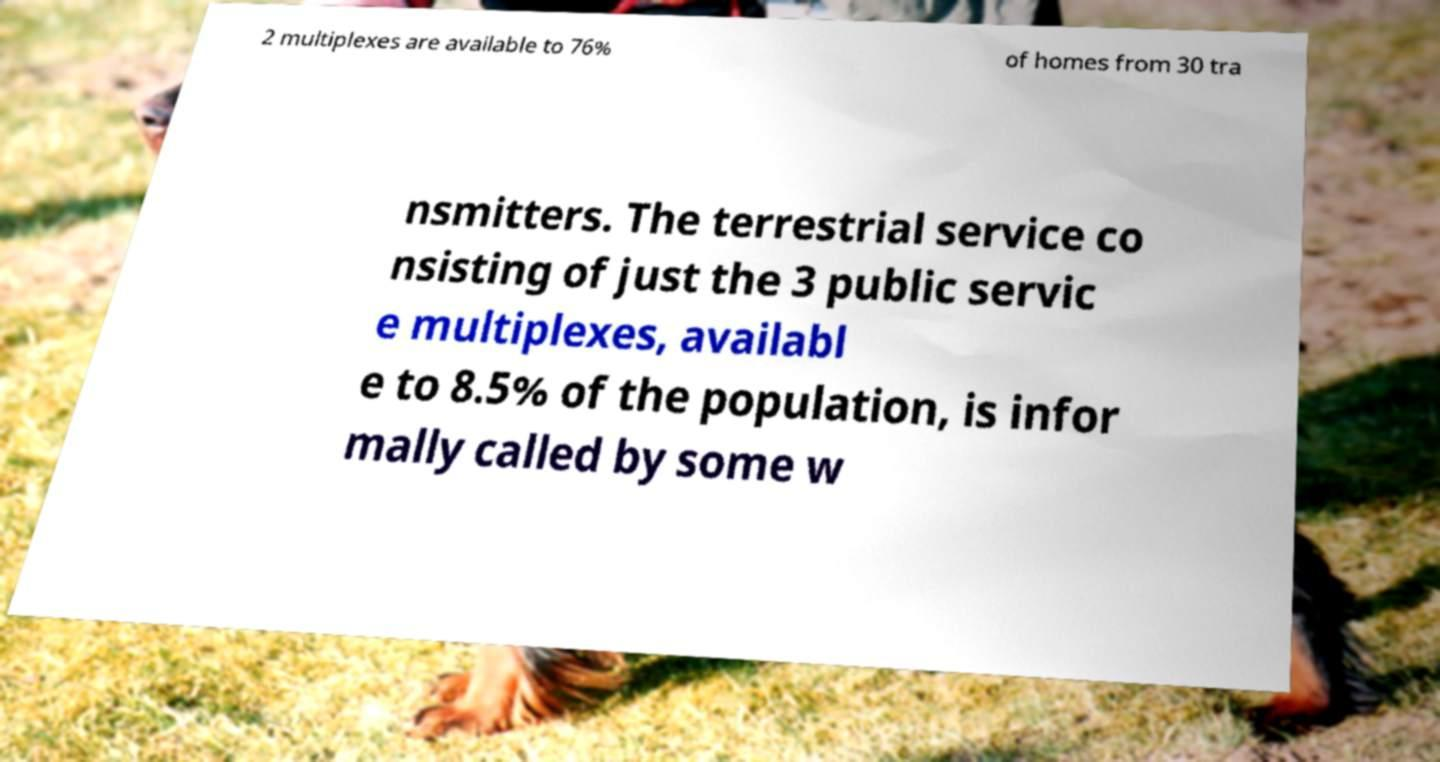Please read and relay the text visible in this image. What does it say? 2 multiplexes are available to 76% of homes from 30 tra nsmitters. The terrestrial service co nsisting of just the 3 public servic e multiplexes, availabl e to 8.5% of the population, is infor mally called by some w 